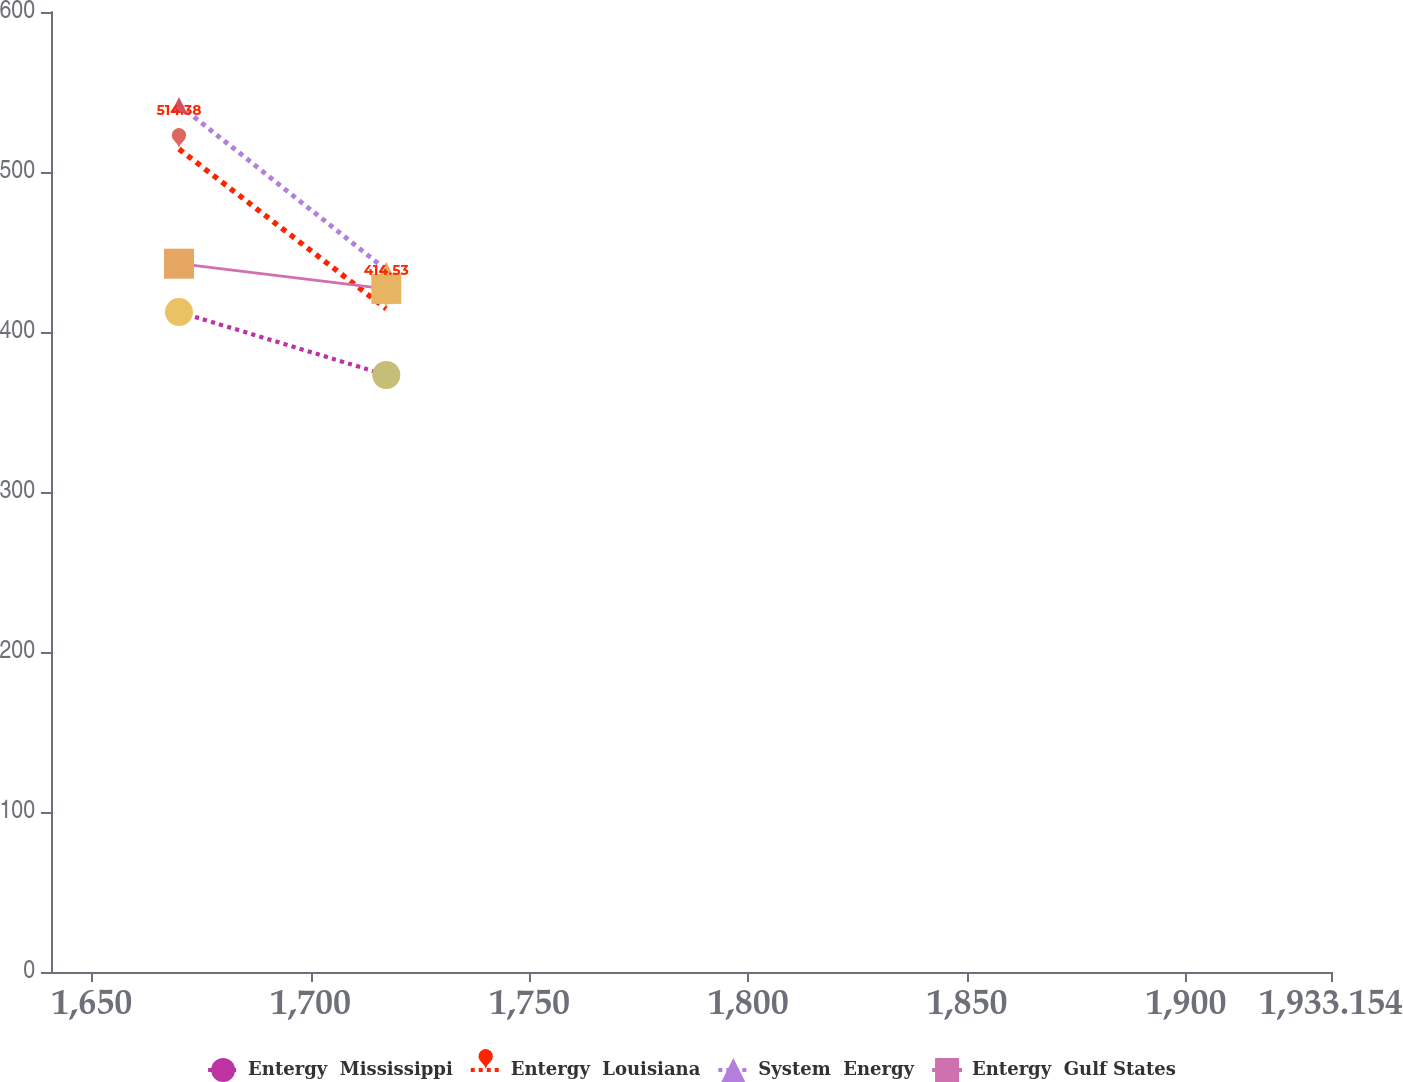Convert chart. <chart><loc_0><loc_0><loc_500><loc_500><line_chart><ecel><fcel>Entergy  Mississippi<fcel>Entergy  Louisiana<fcel>System  Energy<fcel>Entergy  Gulf States<nl><fcel>1669.94<fcel>412.47<fcel>514.38<fcel>541.94<fcel>442.68<nl><fcel>1717.3<fcel>373.11<fcel>414.53<fcel>438.85<fcel>426.92<nl><fcel>1962.4<fcel>528.78<fcel>328.07<fcel>392.04<fcel>271.2<nl></chart> 